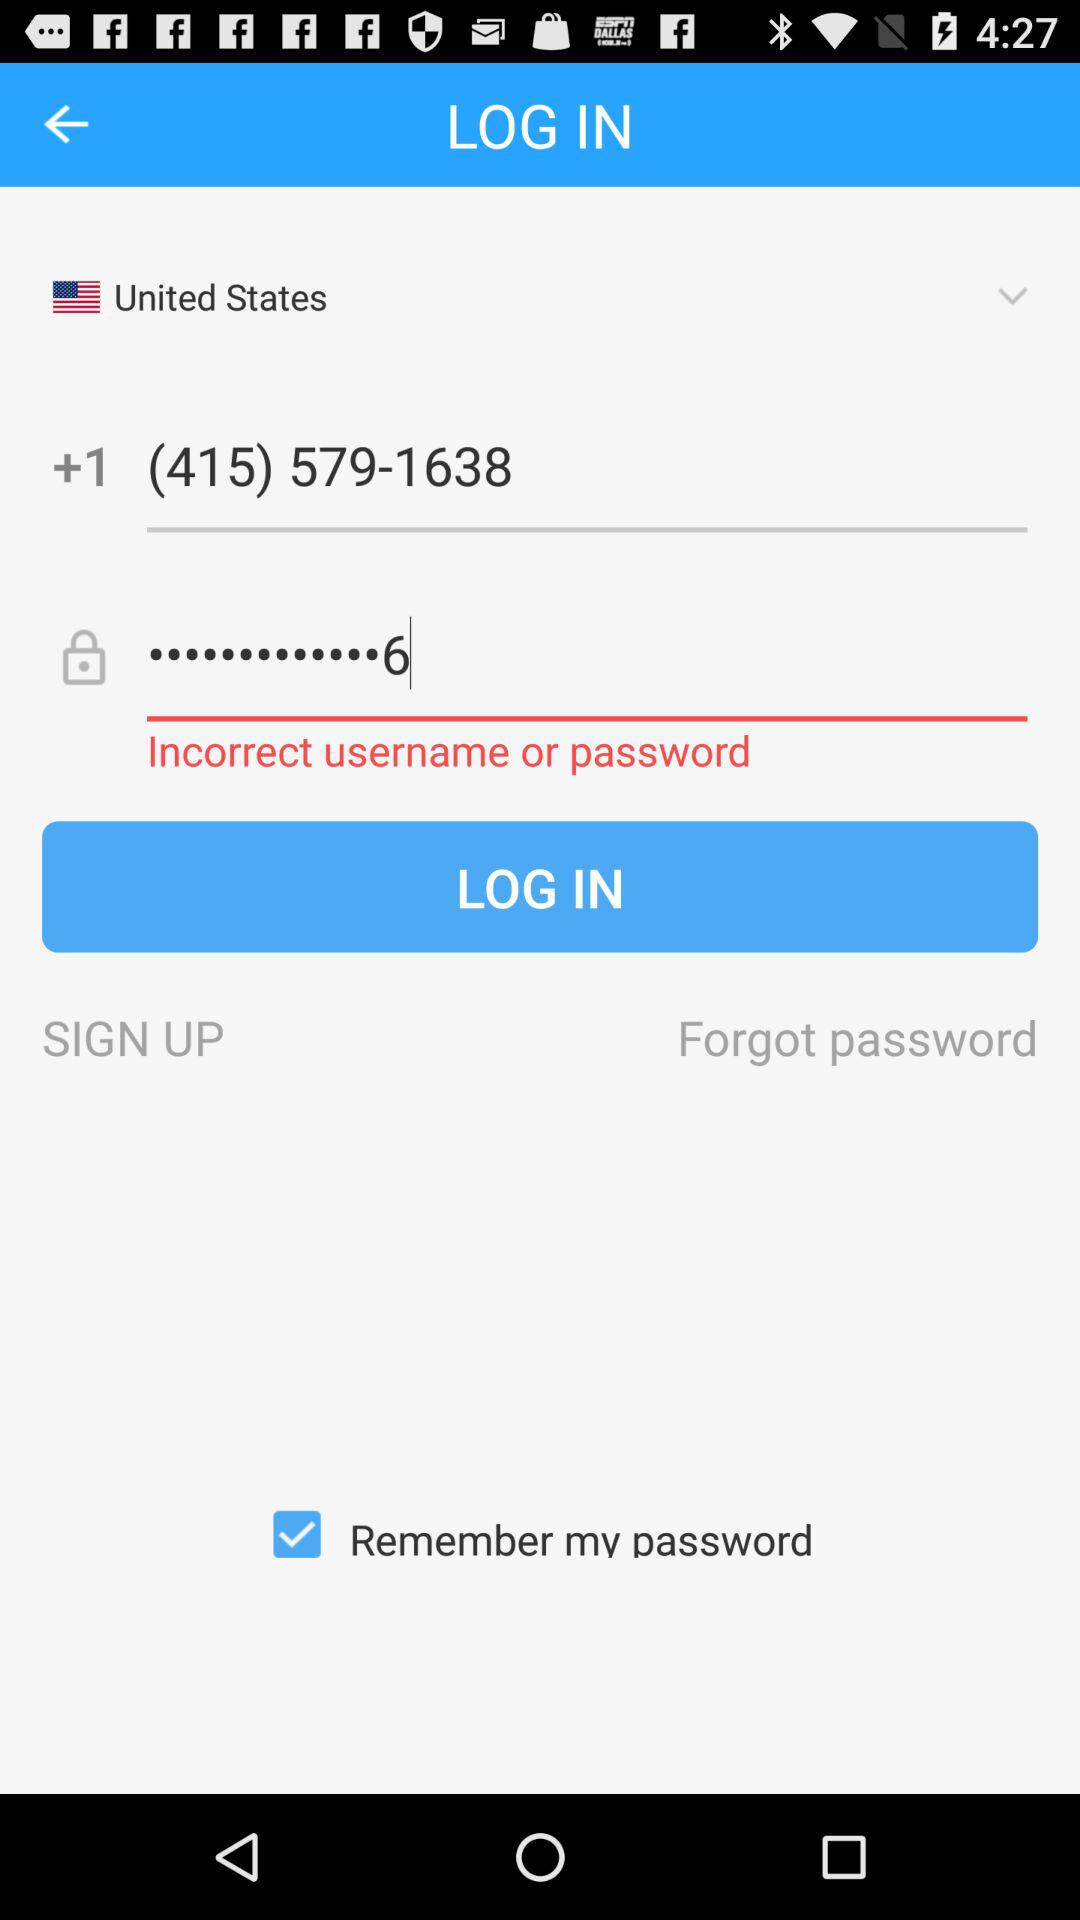What phone number is being used as the username? The phone number is (415) 579-1638. 